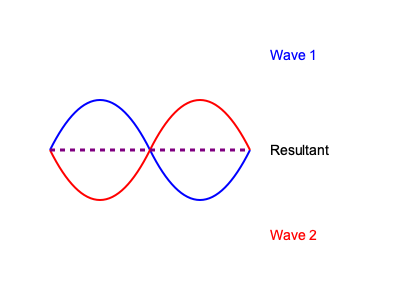In designing a new immersive sound experience for a themed attraction, you encounter the phenomenon illustrated in the image. What type of interference pattern is shown, and how could this be utilized to create a unique auditory effect for riders? To answer this question, let's break down the image and its implications:

1. Wave representation:
   - The blue curve represents Wave 1
   - The red curve represents Wave 2
   - The purple dashed line represents the Resultant wave

2. Interference pattern analysis:
   - The two waves have the same frequency and amplitude
   - They are perfectly out of phase (180° phase difference)
   - The resultant wave is a straight line along the central axis

3. Type of interference:
   - This pattern shows destructive interference
   - When two waves with equal amplitude and frequency are 180° out of phase, they cancel each other out

4. Application in themed attraction:
   - This phenomenon can be used to create "quiet zones" or "sound cancellation areas"
   - By strategically placing speakers emitting out-of-phase waves, you can create areas where certain frequencies are minimized or eliminated

5. Unique auditory effect:
   - Riders could experience sudden transitions between areas of normal sound and areas of reduced or altered sound
   - This could create an illusion of entering different "sound dimensions" or "acoustic environments"
   - It could be used to simulate the effect of passing through barriers or portals in the attraction's narrative

6. Technical implementation:
   - Use multiple speakers positioned to create interference patterns
   - Employ real-time sound processing to adjust phase and amplitude based on rider position
   - Incorporate motion sensors to synchronize sound effects with ride movement

By utilizing destructive interference, you can create a dynamic and immersive soundscape that enhances the overall experience of the attraction, adding an innovative auditory dimension to the ride.
Answer: Destructive interference; create quiet zones or sound cancellation areas for immersive auditory transitions. 